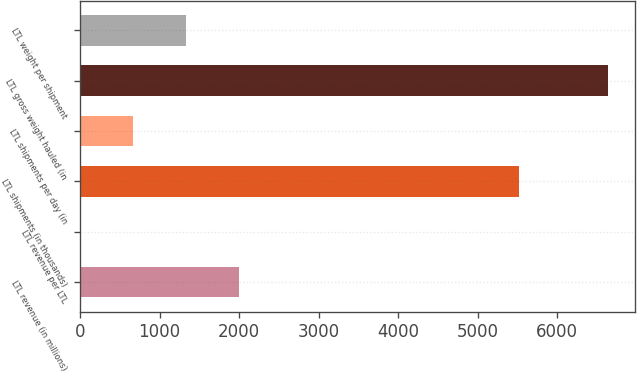Convert chart to OTSL. <chart><loc_0><loc_0><loc_500><loc_500><bar_chart><fcel>LTL revenue (in millions)<fcel>LTL revenue per LTL<fcel>LTL shipments (in thousands)<fcel>LTL shipments per day (in<fcel>LTL gross weight hauled (in<fcel>LTL weight per shipment<nl><fcel>1993.18<fcel>0.4<fcel>5525<fcel>664.66<fcel>6643<fcel>1328.92<nl></chart> 